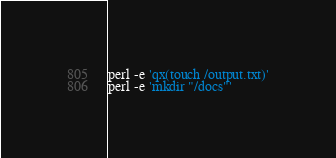<code> <loc_0><loc_0><loc_500><loc_500><_Perl_>perl -e 'qx(touch /output.txt)'
perl -e 'mkdir "/docs"'
</code> 